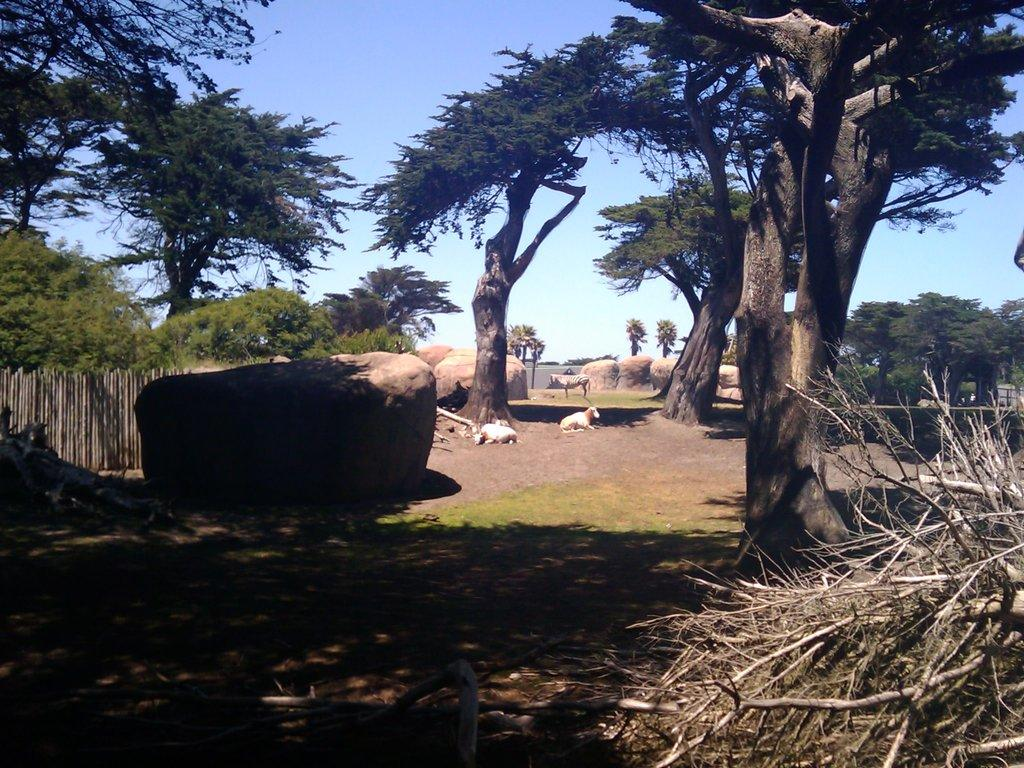What types of living organisms can be seen in the image? There are animals in the image. What geological features are present in the image? There are rocks in the image. What type of vegetation can be seen in the image? There are trees in the image. What type of brick structure can be seen in the image? There is no brick structure present in the image. What type of camp can be seen in the image? There is no camp present in the image. 